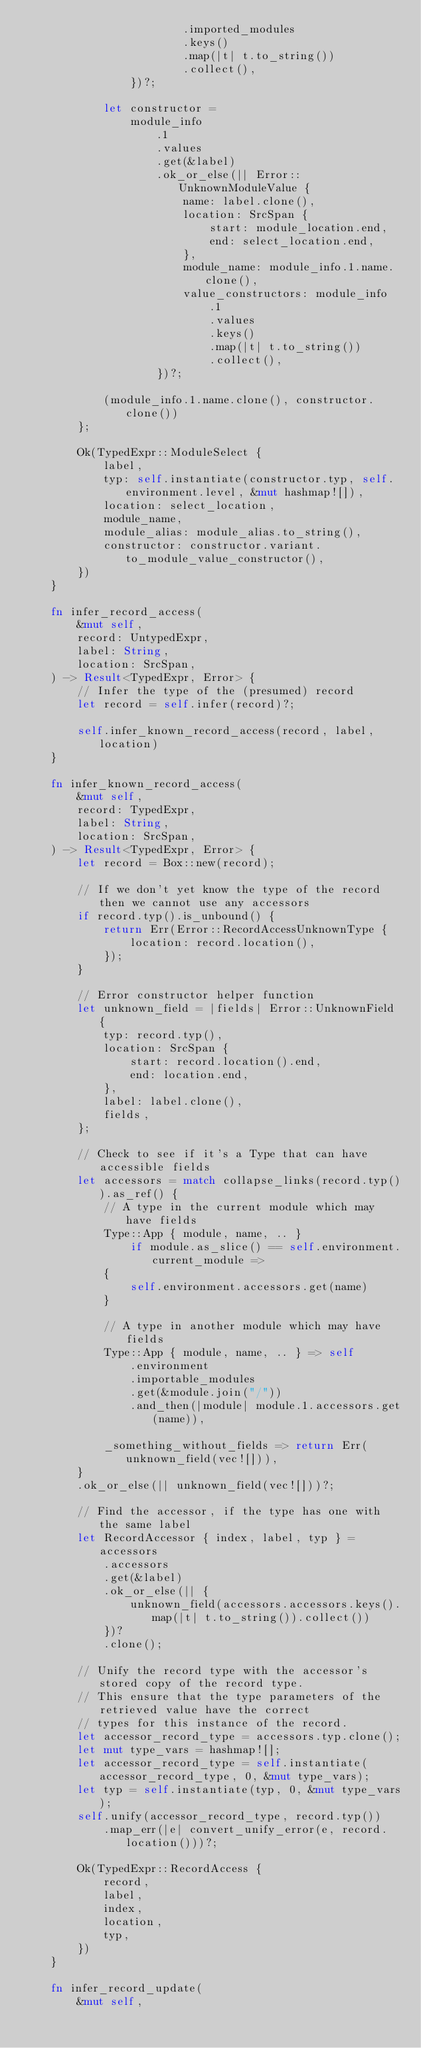Convert code to text. <code><loc_0><loc_0><loc_500><loc_500><_Rust_>                        .imported_modules
                        .keys()
                        .map(|t| t.to_string())
                        .collect(),
                })?;

            let constructor =
                module_info
                    .1
                    .values
                    .get(&label)
                    .ok_or_else(|| Error::UnknownModuleValue {
                        name: label.clone(),
                        location: SrcSpan {
                            start: module_location.end,
                            end: select_location.end,
                        },
                        module_name: module_info.1.name.clone(),
                        value_constructors: module_info
                            .1
                            .values
                            .keys()
                            .map(|t| t.to_string())
                            .collect(),
                    })?;

            (module_info.1.name.clone(), constructor.clone())
        };

        Ok(TypedExpr::ModuleSelect {
            label,
            typ: self.instantiate(constructor.typ, self.environment.level, &mut hashmap![]),
            location: select_location,
            module_name,
            module_alias: module_alias.to_string(),
            constructor: constructor.variant.to_module_value_constructor(),
        })
    }

    fn infer_record_access(
        &mut self,
        record: UntypedExpr,
        label: String,
        location: SrcSpan,
    ) -> Result<TypedExpr, Error> {
        // Infer the type of the (presumed) record
        let record = self.infer(record)?;

        self.infer_known_record_access(record, label, location)
    }

    fn infer_known_record_access(
        &mut self,
        record: TypedExpr,
        label: String,
        location: SrcSpan,
    ) -> Result<TypedExpr, Error> {
        let record = Box::new(record);

        // If we don't yet know the type of the record then we cannot use any accessors
        if record.typ().is_unbound() {
            return Err(Error::RecordAccessUnknownType {
                location: record.location(),
            });
        }

        // Error constructor helper function
        let unknown_field = |fields| Error::UnknownField {
            typ: record.typ(),
            location: SrcSpan {
                start: record.location().end,
                end: location.end,
            },
            label: label.clone(),
            fields,
        };

        // Check to see if it's a Type that can have accessible fields
        let accessors = match collapse_links(record.typ()).as_ref() {
            // A type in the current module which may have fields
            Type::App { module, name, .. }
                if module.as_slice() == self.environment.current_module =>
            {
                self.environment.accessors.get(name)
            }

            // A type in another module which may have fields
            Type::App { module, name, .. } => self
                .environment
                .importable_modules
                .get(&module.join("/"))
                .and_then(|module| module.1.accessors.get(name)),

            _something_without_fields => return Err(unknown_field(vec![])),
        }
        .ok_or_else(|| unknown_field(vec![]))?;

        // Find the accessor, if the type has one with the same label
        let RecordAccessor { index, label, typ } = accessors
            .accessors
            .get(&label)
            .ok_or_else(|| {
                unknown_field(accessors.accessors.keys().map(|t| t.to_string()).collect())
            })?
            .clone();

        // Unify the record type with the accessor's stored copy of the record type.
        // This ensure that the type parameters of the retrieved value have the correct
        // types for this instance of the record.
        let accessor_record_type = accessors.typ.clone();
        let mut type_vars = hashmap![];
        let accessor_record_type = self.instantiate(accessor_record_type, 0, &mut type_vars);
        let typ = self.instantiate(typ, 0, &mut type_vars);
        self.unify(accessor_record_type, record.typ())
            .map_err(|e| convert_unify_error(e, record.location()))?;

        Ok(TypedExpr::RecordAccess {
            record,
            label,
            index,
            location,
            typ,
        })
    }

    fn infer_record_update(
        &mut self,</code> 